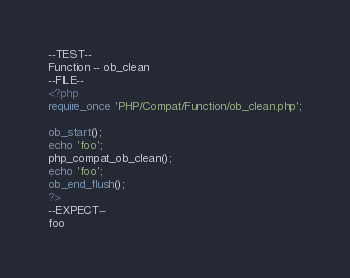<code> <loc_0><loc_0><loc_500><loc_500><_PHP_>--TEST--
Function -- ob_clean
--FILE--
<?php
require_once 'PHP/Compat/Function/ob_clean.php';

ob_start();
echo 'foo';
php_compat_ob_clean();
echo 'foo';
ob_end_flush();
?>
--EXPECT--
foo</code> 